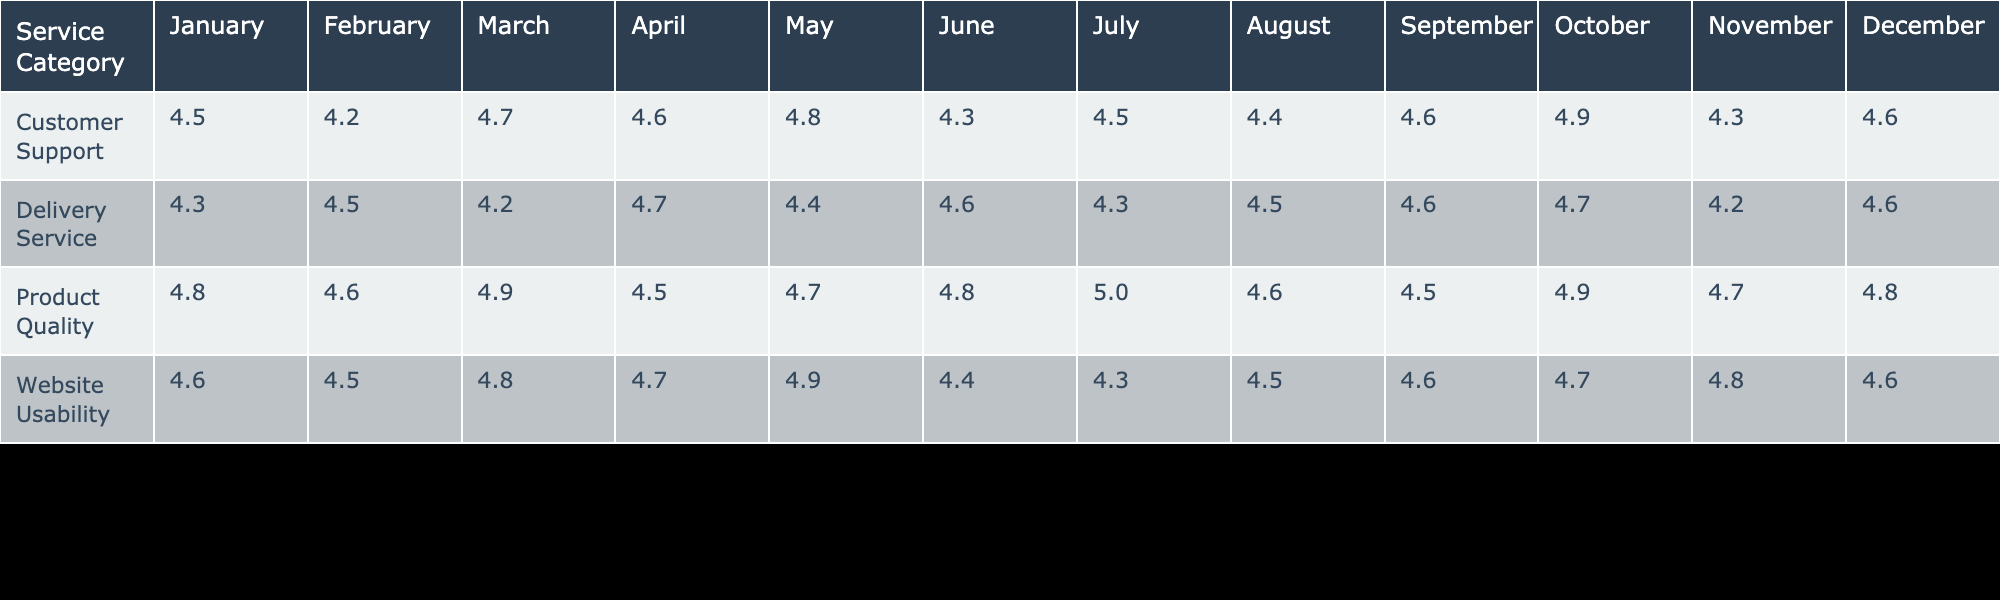What is the highest feedback rating for Product Quality? The maximum rating for Product Quality can be found by comparing the values across all months listed for that service category. Looking through the table, the highest value for Product Quality appears in July with a rating of 5.0.
Answer: 5.0 What is the average feedback rating for Customer Support in the summer months (June, July, August)? To find the average for Customer Support in summer, we take the ratings for June (4.3), July (4.5), and August (4.4). The sum is (4.3 + 4.5 + 4.4) = 13.2, and there are 3 months, resulting in an average of 13.2/3 = 4.4.
Answer: 4.4 Did the Delivery Service receive a rating higher than 4.5 in any month? By checking each month for Delivery Service, we observe that the ratings in October (4.7) is greater than 4.5. Thus, yes, it did receive a higher rating in that month.
Answer: Yes What is the feedback rating trend for Website Usability from January to December? Analyzing the values of Website Usability across months reveals fluctuations. January is 4.6, February is 4.5, March is 4.8, reaching a peak of 4.9 in May, followed by a decline to 4.3 in July, then recovering to 4.6 in December. The trend shows variability throughout the year.
Answer: Variable trend Which service category had the lowest average rating across the year? The average ratings for each category are computed by adding their monthly ratings and dividing by 12. The sums are Customer Support: 4.54, Product Quality: 4.68, Delivery Service: 4.49, Website Usability: 4.55. Delivery Service has the lowest average at 4.49.
Answer: Delivery Service Which month had the highest rating overall across all service categories? The highest rating among all categories in each month needs to be compared. January's highest is 4.8 (Product Quality), while in April it's 4.7 (Delivery Service) and in July, Product Quality peaks at 5.0. The highest overall across all months is July at 5.0.
Answer: July Is the feedback rating for Delivery Service consistent throughout the year? To determine consistency, we look at the variation in ratings each month. The ratings are 4.3, 4.5, 4.2, 4.7, 4.4, 4.6, 4.3, 4.5, 4.6, 4.7, 4.2, 4.6. Noticing the ups and downs shows significant fluctuations, indicating it is not consistent.
Answer: No What is the difference in the average ratings between Product Quality and Delivery Service? For Product Quality, the sum of ratings is 56.4 (average 4.68) and for Delivery Service, it is 53.9 (average 4.49). The difference is 4.68 - 4.49 = 0.19, indicating that Product Quality is higher on average.
Answer: 0.19 Which service category had the most stable ratings, based on the least variation? To find the most stable category, we need to calculate the standard deviation or observe the range of ratings per category. Product Quality shows the least fluctuation in its monthly ratings compared to the others, indicating it's the most stable.
Answer: Product Quality 